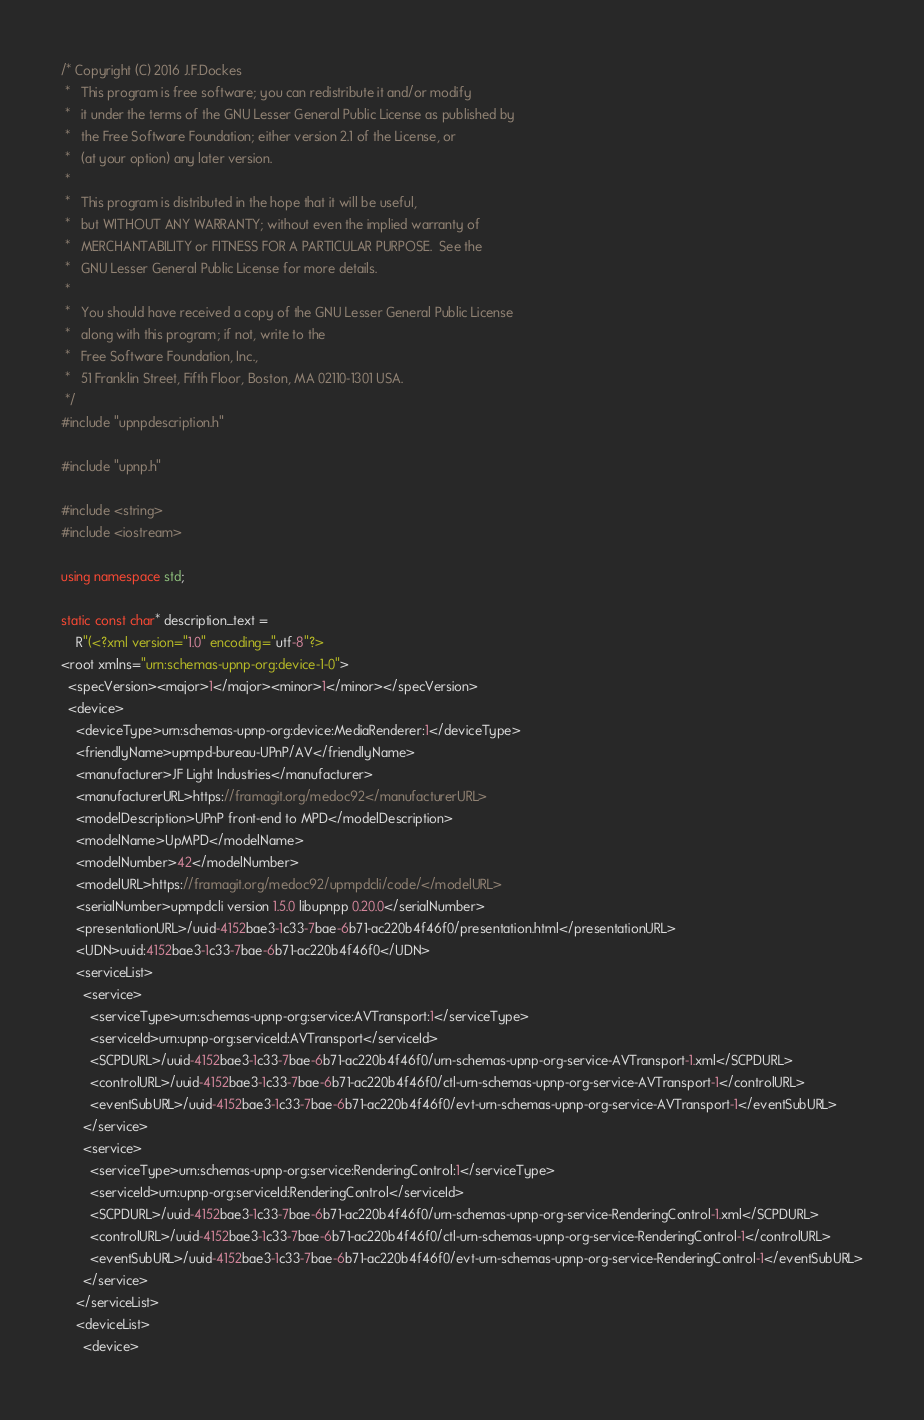<code> <loc_0><loc_0><loc_500><loc_500><_C++_>/* Copyright (C) 2016 J.F.Dockes
 *   This program is free software; you can redistribute it and/or modify
 *   it under the terms of the GNU Lesser General Public License as published by
 *   the Free Software Foundation; either version 2.1 of the License, or
 *   (at your option) any later version.
 *
 *   This program is distributed in the hope that it will be useful,
 *   but WITHOUT ANY WARRANTY; without even the implied warranty of
 *   MERCHANTABILITY or FITNESS FOR A PARTICULAR PURPOSE.  See the
 *   GNU Lesser General Public License for more details.
 *
 *   You should have received a copy of the GNU Lesser General Public License
 *   along with this program; if not, write to the
 *   Free Software Foundation, Inc.,
 *   51 Franklin Street, Fifth Floor, Boston, MA 02110-1301 USA.
 */
#include "upnpdescription.h"

#include "upnp.h"

#include <string>
#include <iostream>

using namespace std;

static const char* description_text =
    R"(<?xml version="1.0" encoding="utf-8"?>
<root xmlns="urn:schemas-upnp-org:device-1-0">
  <specVersion><major>1</major><minor>1</minor></specVersion>
  <device>
    <deviceType>urn:schemas-upnp-org:device:MediaRenderer:1</deviceType>
    <friendlyName>upmpd-bureau-UPnP/AV</friendlyName>
    <manufacturer>JF Light Industries</manufacturer>
    <manufacturerURL>https://framagit.org/medoc92</manufacturerURL>
    <modelDescription>UPnP front-end to MPD</modelDescription>
    <modelName>UpMPD</modelName>
    <modelNumber>42</modelNumber>
    <modelURL>https://framagit.org/medoc92/upmpdcli/code/</modelURL>
    <serialNumber>upmpdcli version 1.5.0 libupnpp 0.20.0</serialNumber>
    <presentationURL>/uuid-4152bae3-1c33-7bae-6b71-ac220b4f46f0/presentation.html</presentationURL>    
    <UDN>uuid:4152bae3-1c33-7bae-6b71-ac220b4f46f0</UDN>
    <serviceList>
      <service>
        <serviceType>urn:schemas-upnp-org:service:AVTransport:1</serviceType>
        <serviceId>urn:upnp-org:serviceId:AVTransport</serviceId>
        <SCPDURL>/uuid-4152bae3-1c33-7bae-6b71-ac220b4f46f0/urn-schemas-upnp-org-service-AVTransport-1.xml</SCPDURL>
        <controlURL>/uuid-4152bae3-1c33-7bae-6b71-ac220b4f46f0/ctl-urn-schemas-upnp-org-service-AVTransport-1</controlURL>
        <eventSubURL>/uuid-4152bae3-1c33-7bae-6b71-ac220b4f46f0/evt-urn-schemas-upnp-org-service-AVTransport-1</eventSubURL>
      </service>
      <service>
        <serviceType>urn:schemas-upnp-org:service:RenderingControl:1</serviceType>
        <serviceId>urn:upnp-org:serviceId:RenderingControl</serviceId>
        <SCPDURL>/uuid-4152bae3-1c33-7bae-6b71-ac220b4f46f0/urn-schemas-upnp-org-service-RenderingControl-1.xml</SCPDURL>
        <controlURL>/uuid-4152bae3-1c33-7bae-6b71-ac220b4f46f0/ctl-urn-schemas-upnp-org-service-RenderingControl-1</controlURL>
        <eventSubURL>/uuid-4152bae3-1c33-7bae-6b71-ac220b4f46f0/evt-urn-schemas-upnp-org-service-RenderingControl-1</eventSubURL>
      </service>
    </serviceList>
    <deviceList>
      <device></code> 